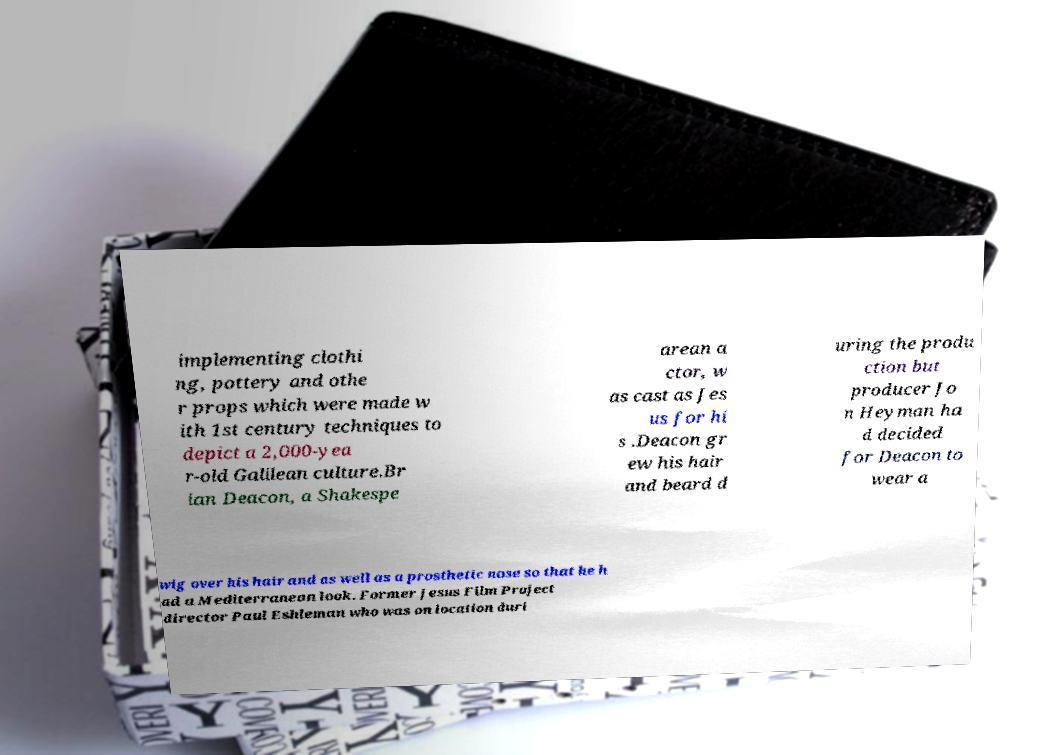Can you read and provide the text displayed in the image?This photo seems to have some interesting text. Can you extract and type it out for me? implementing clothi ng, pottery and othe r props which were made w ith 1st century techniques to depict a 2,000-yea r-old Galilean culture.Br ian Deacon, a Shakespe arean a ctor, w as cast as Jes us for hi s .Deacon gr ew his hair and beard d uring the produ ction but producer Jo n Heyman ha d decided for Deacon to wear a wig over his hair and as well as a prosthetic nose so that he h ad a Mediterranean look. Former Jesus Film Project director Paul Eshleman who was on location duri 